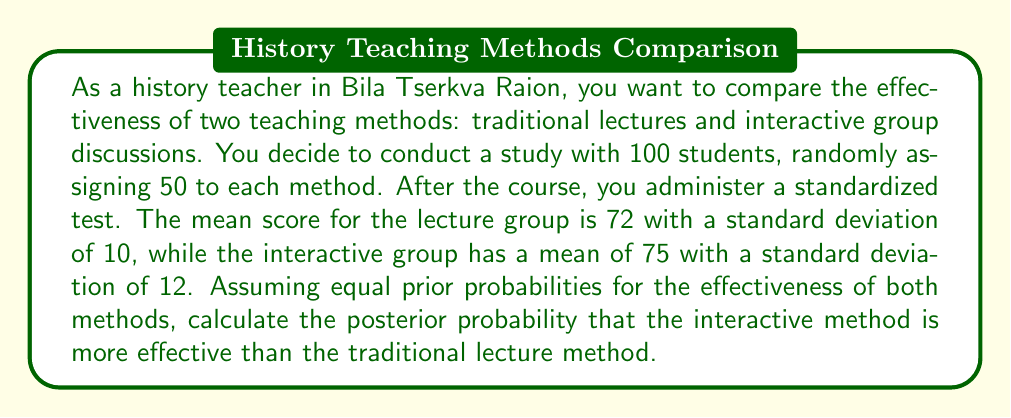Show me your answer to this math problem. To solve this problem using Bayesian hypothesis testing, we'll follow these steps:

1) Define our hypotheses:
   $H_0$: Traditional lectures are more effective or equally effective
   $H_1$: Interactive discussions are more effective

2) Assign prior probabilities:
   $P(H_0) = P(H_1) = 0.5$ (equal prior probabilities)

3) Calculate the likelihood of the data given each hypothesis. We can use the t-statistic for this:

   $t = \frac{\bar{X}_1 - \bar{X}_2}{\sqrt{\frac{s_1^2}{n_1} + \frac{s_2^2}{n_2}}}$

   Where:
   $\bar{X}_1 = 75$ (interactive mean)
   $\bar{X}_2 = 72$ (lecture mean)
   $s_1 = 12$ (interactive std dev)
   $s_2 = 10$ (lecture std dev)
   $n_1 = n_2 = 50$ (sample sizes)

   $t = \frac{75 - 72}{\sqrt{\frac{12^2}{50} + \frac{10^2}{50}}} = \frac{3}{\sqrt{4.08}} = 1.484$

4) Calculate the p-value for this t-statistic (one-tailed test):
   $p = P(T > 1.484) \approx 0.0703$

5) The likelihood of the data given $H_1$ is $1 - p = 0.9297$
   The likelihood of the data given $H_0$ is $p = 0.0703$

6) Apply Bayes' theorem:

   $P(H_1|D) = \frac{P(D|H_1)P(H_1)}{P(D|H_1)P(H_1) + P(D|H_0)P(H_0)}$

   $= \frac{0.9297 * 0.5}{0.9297 * 0.5 + 0.0703 * 0.5}$

   $= \frac{0.46485}{0.46485 + 0.03515}$

   $= \frac{0.46485}{0.5} = 0.9297$

Therefore, the posterior probability that the interactive method is more effective is approximately 0.9297 or 92.97%.
Answer: The posterior probability that the interactive discussion method is more effective than the traditional lecture method is approximately 0.9297 or 92.97%. 